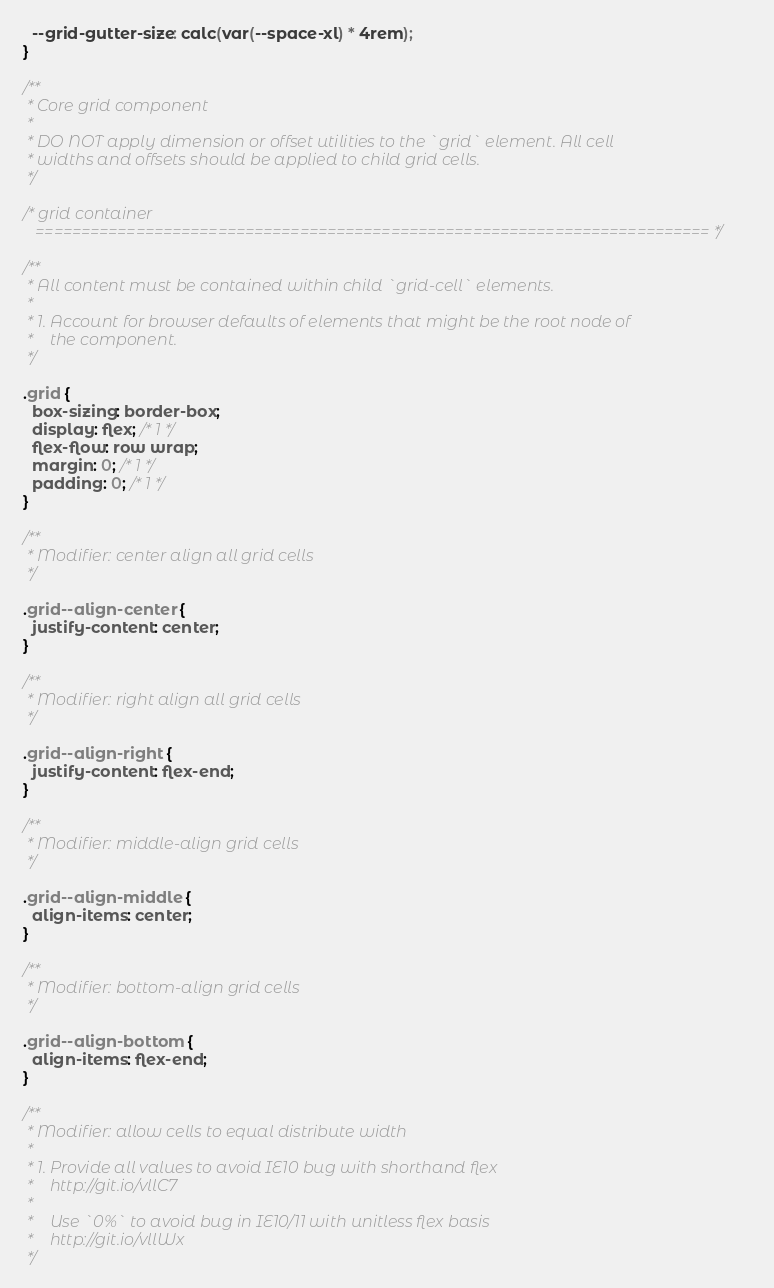<code> <loc_0><loc_0><loc_500><loc_500><_CSS_>  --grid-gutter-size: calc(var(--space-xl) * 4rem);
}

/**
 * Core grid component
 *
 * DO NOT apply dimension or offset utilities to the `grid` element. All cell
 * widths and offsets should be applied to child grid cells.
 */

/* grid container
   ========================================================================== */

/**
 * All content must be contained within child `grid-cell` elements.
 *
 * 1. Account for browser defaults of elements that might be the root node of
 *    the component.
 */

.grid {
  box-sizing: border-box;
  display: flex; /* 1 */
  flex-flow: row wrap;
  margin: 0; /* 1 */
  padding: 0; /* 1 */
}

/**
 * Modifier: center align all grid cells
 */

.grid--align-center {
  justify-content: center;
}

/**
 * Modifier: right align all grid cells
 */

.grid--align-right {
  justify-content: flex-end;
}

/**
 * Modifier: middle-align grid cells
 */

.grid--align-middle {
  align-items: center;
}

/**
 * Modifier: bottom-align grid cells
 */

.grid--align-bottom {
  align-items: flex-end;
}

/**
 * Modifier: allow cells to equal distribute width
 *
 * 1. Provide all values to avoid IE10 bug with shorthand flex
 *    http://git.io/vllC7
 *
 *    Use `0%` to avoid bug in IE10/11 with unitless flex basis
 *    http://git.io/vllWx
 */
</code> 